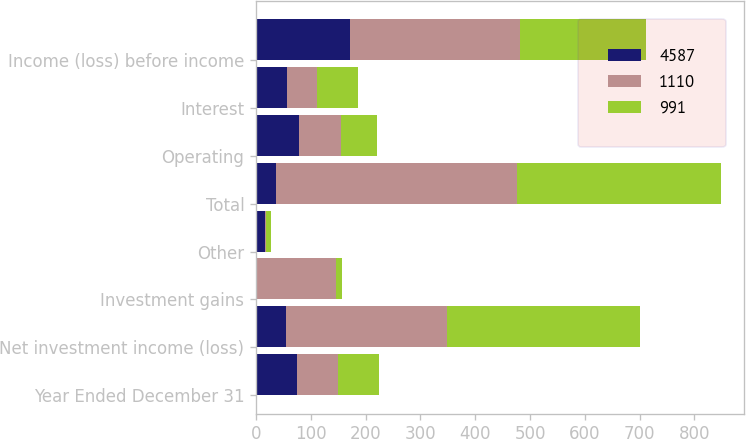<chart> <loc_0><loc_0><loc_500><loc_500><stacked_bar_chart><ecel><fcel>Year Ended December 31<fcel>Net investment income (loss)<fcel>Investment gains<fcel>Other<fcel>Total<fcel>Operating<fcel>Interest<fcel>Income (loss) before income<nl><fcel>4587<fcel>75<fcel>54<fcel>2<fcel>16<fcel>36<fcel>79<fcel>56<fcel>171<nl><fcel>1110<fcel>75<fcel>295<fcel>144<fcel>2<fcel>441<fcel>76<fcel>55<fcel>310<nl><fcel>991<fcel>75<fcel>351<fcel>10<fcel>10<fcel>371<fcel>65<fcel>75<fcel>231<nl></chart> 